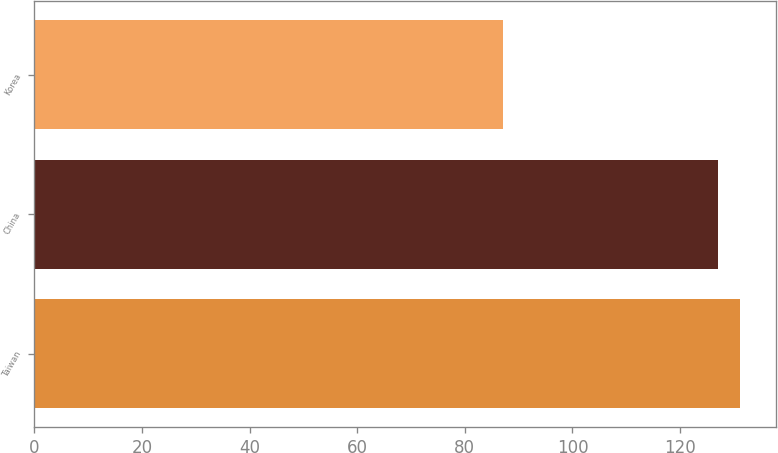<chart> <loc_0><loc_0><loc_500><loc_500><bar_chart><fcel>Taiwan<fcel>China<fcel>Korea<nl><fcel>131.2<fcel>127<fcel>87<nl></chart> 